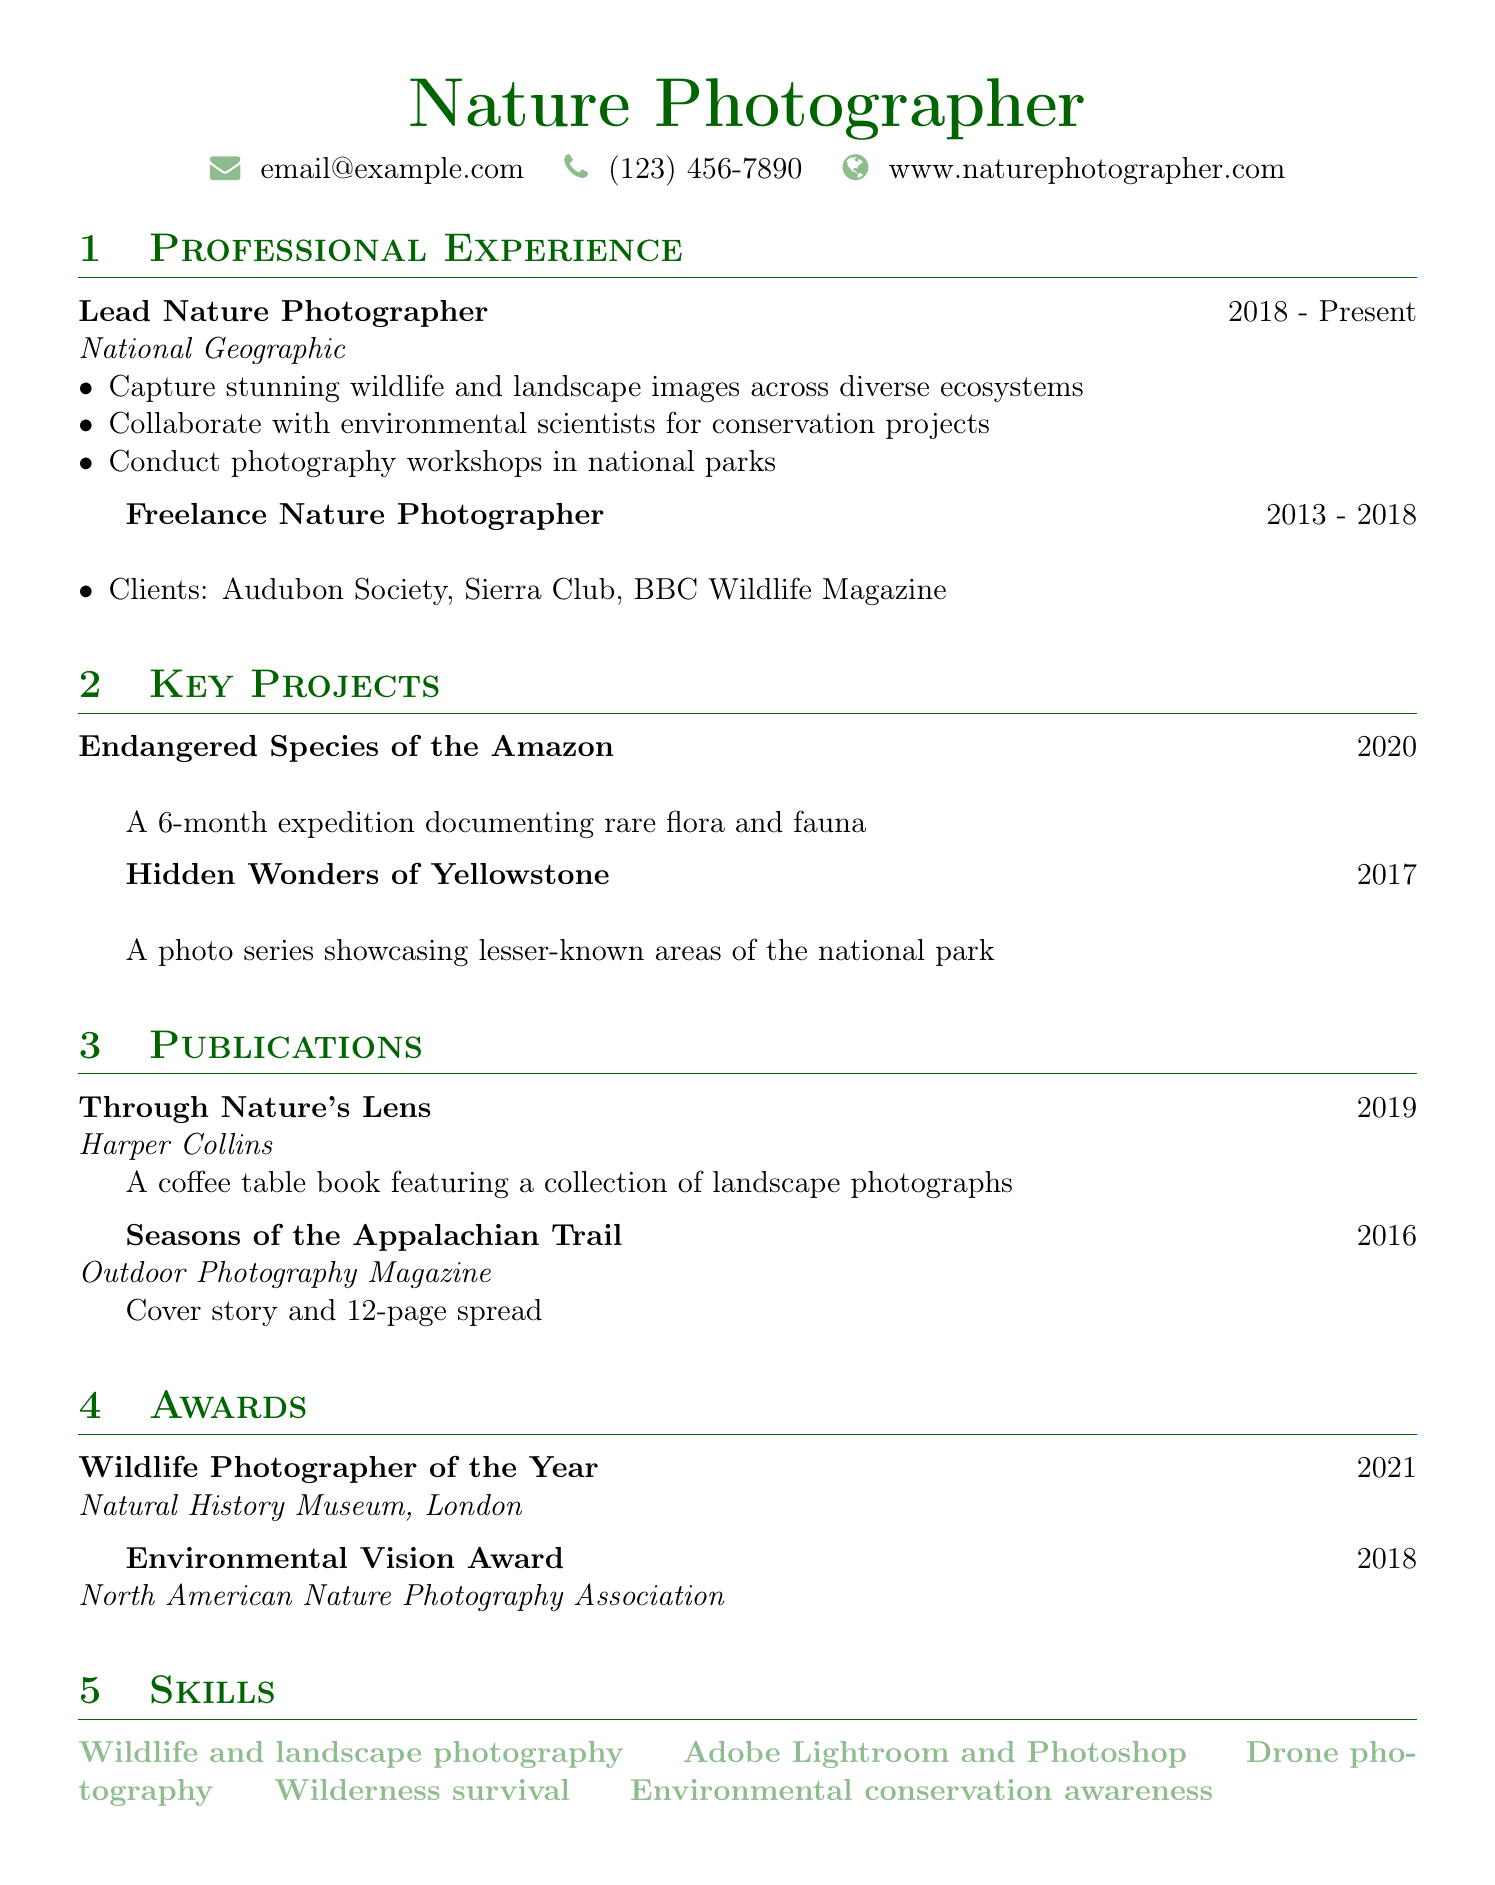what is the position held at National Geographic? The document states the individual is the Lead Nature Photographer at National Geographic.
Answer: Lead Nature Photographer what year did the individual start working as a freelancer? The transition to freelance photography began in 2013, according to the document.
Answer: 2013 what is the title of the coffee table book published in 2019? The document lists "Through Nature's Lens" as the published coffee table book in 2019.
Answer: Through Nature's Lens which award was received in 2021? The document mentions the award "Wildlife Photographer of the Year" was received in 2021.
Answer: Wildlife Photographer of the Year how many projects are listed under key projects? There are two key projects outlined in the document regarding the individual's work.
Answer: 2 who are three clients from the freelance experience? The document names Audubon Society, Sierra Club, and BBC Wildlife Magazine as clients.
Answer: Audubon Society, Sierra Club, BBC Wildlife Magazine what skill is highlighted related to post-processing software? The document indicates proficiency in Adobe Lightroom and Photoshop as a key skill.
Answer: Adobe Lightroom and Photoshop what is the focus of the project "Endangered Species of the Amazon"? This project is centered around documenting rare flora and fauna, as described in the document.
Answer: Documenting rare flora and fauna how long did the expedition for "Endangered Species of the Amazon" last? The document states that the expedition lasted for six months.
Answer: 6 months 